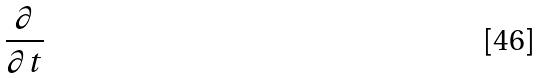Convert formula to latex. <formula><loc_0><loc_0><loc_500><loc_500>\frac { \partial } { \partial t }</formula> 